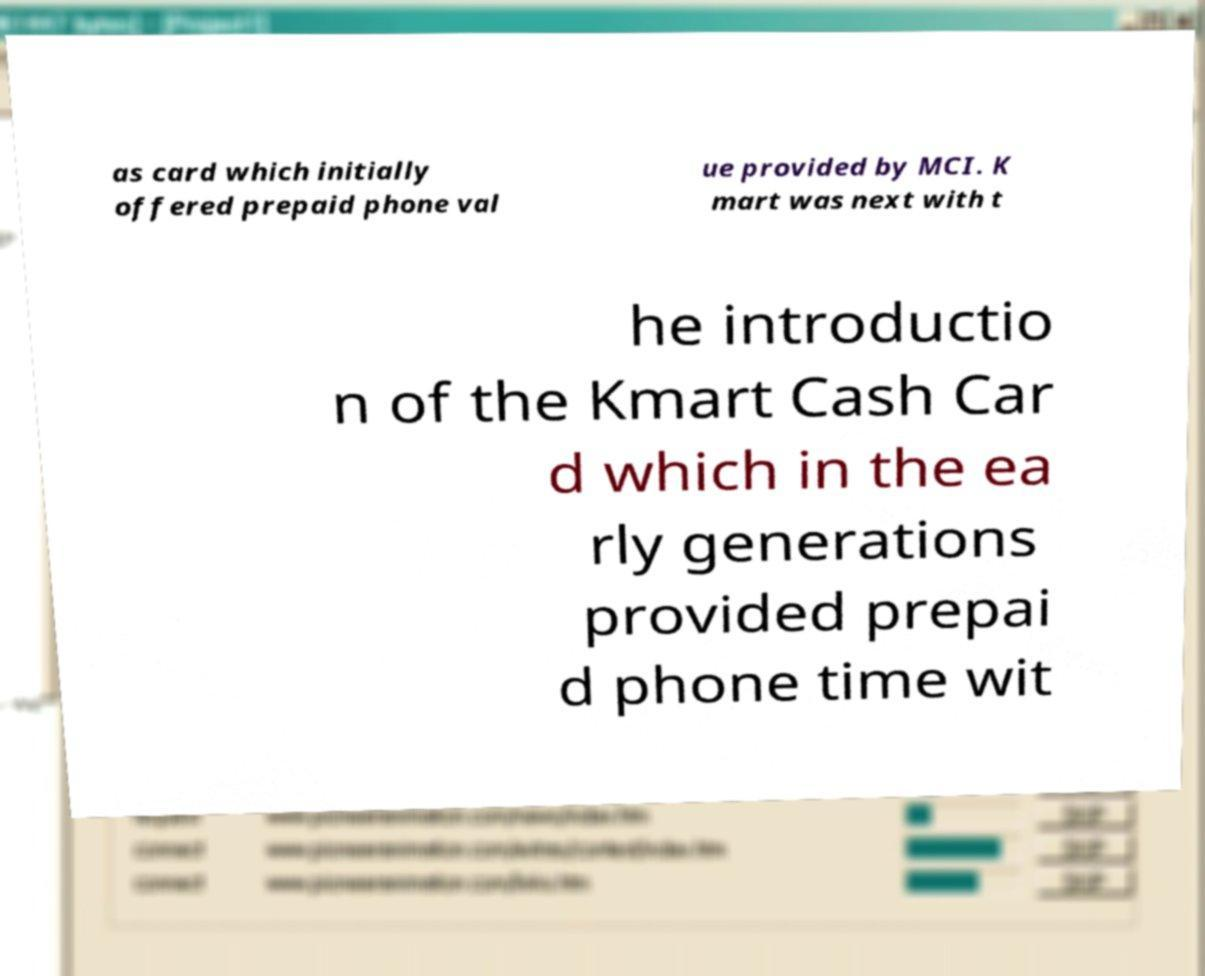Can you accurately transcribe the text from the provided image for me? as card which initially offered prepaid phone val ue provided by MCI. K mart was next with t he introductio n of the Kmart Cash Car d which in the ea rly generations provided prepai d phone time wit 